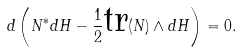Convert formula to latex. <formula><loc_0><loc_0><loc_500><loc_500>d \left ( N ^ { * } d H - \frac { 1 } { 2 } \text {tr} ( N ) \wedge d H \right ) = 0 .</formula> 